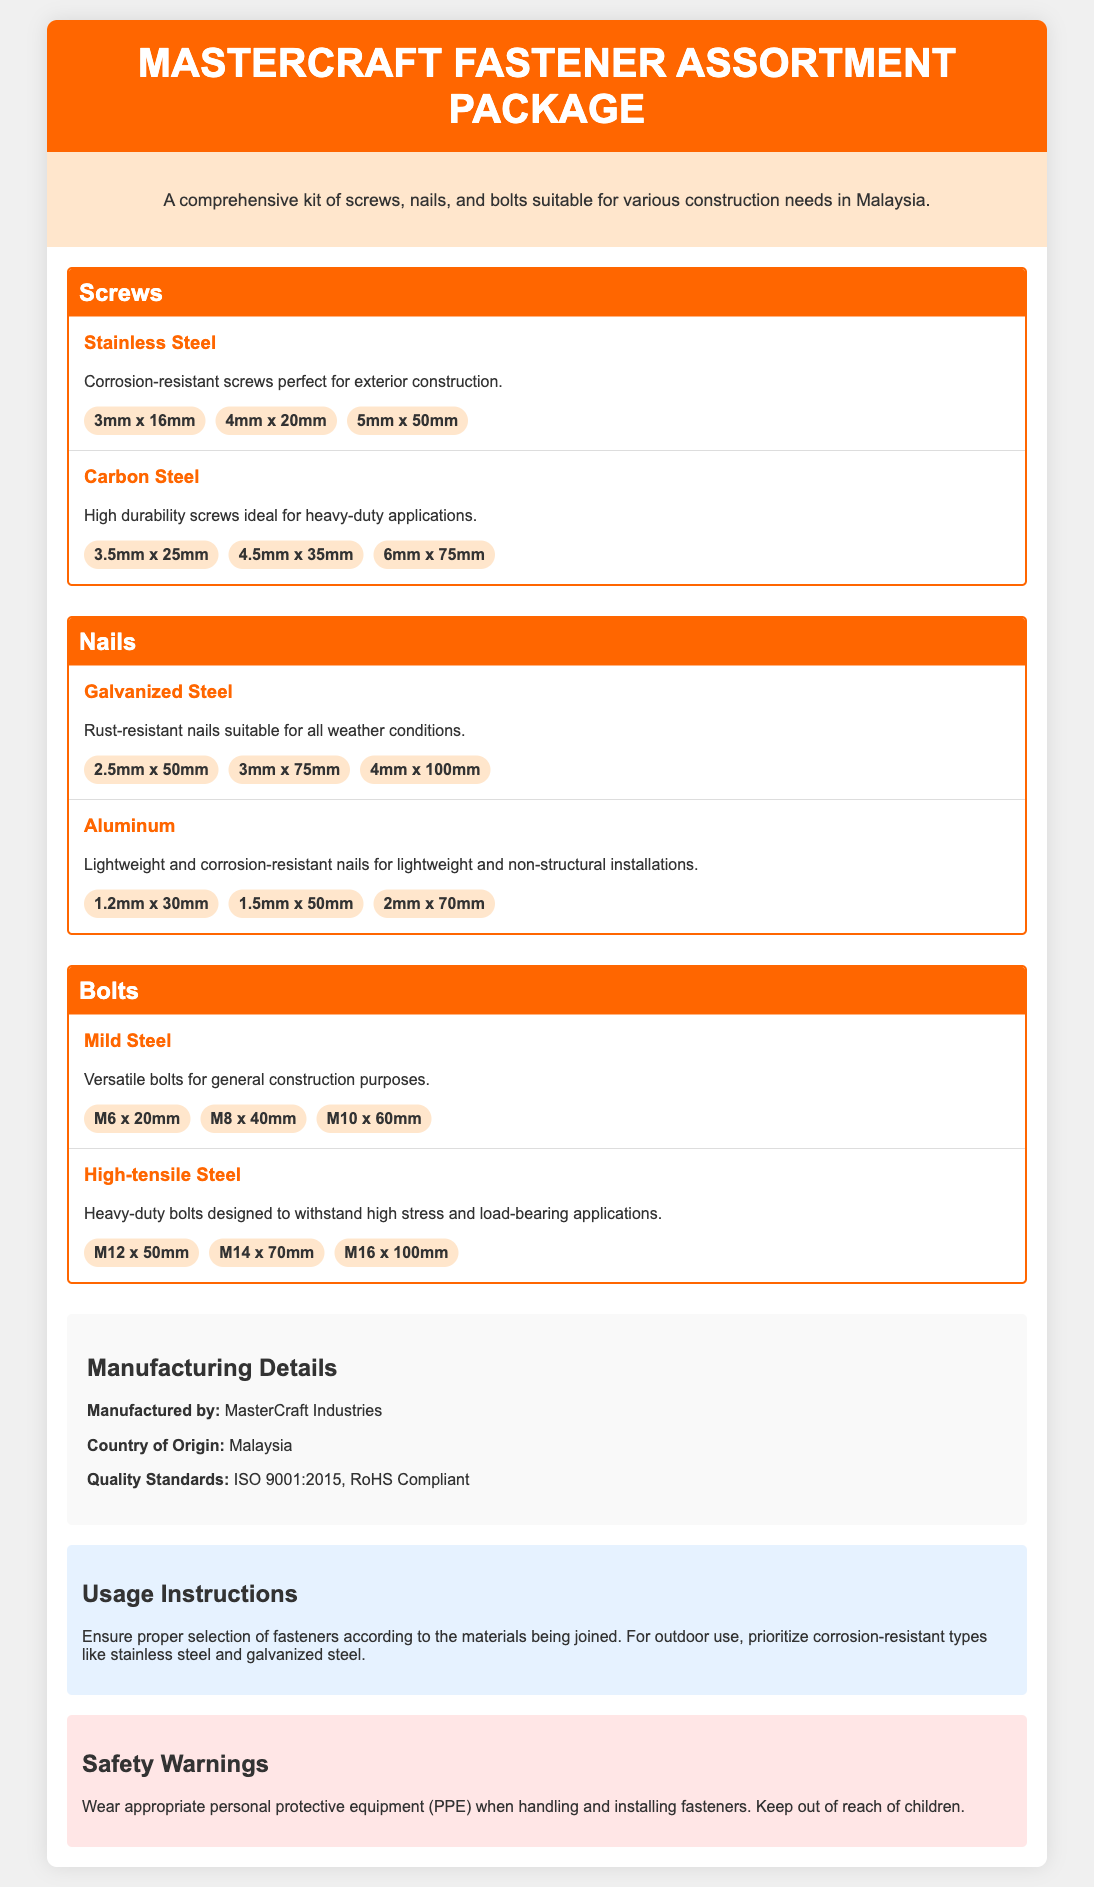What is the product name? The product name is displayed prominently in the header of the document, which is "MasterCraft Fastener Assortment Package."
Answer: MasterCraft Fastener Assortment Package How many types of screws are listed? The document categorizes fasteners into screws, nails, and bolts, specifically stating the types of screws included. There are two types listed: Stainless Steel and Carbon Steel.
Answer: 2 What material type is used for nails? The document mentions two material types for nails: Galvanized Steel and Aluminum.
Answer: Galvanized Steel, Aluminum What size variant is available for stainless steel screws? The document lists the specific sizes available for stainless steel screws, showing components such as "3mm x 16mm," "4mm x 20mm," and "5mm x 50mm."
Answer: 3mm x 16mm, 4mm x 20mm, 5mm x 50mm Who manufactures the fastener assortment package? The document specifies the manufacturer under the section "Manufacturing Details," stating "MasterCraft Industries."
Answer: MasterCraft Industries What safety warning is provided in the document? The document includes a safety warning that mentions the importance of wearing appropriate personal protective equipment and keeping the fasteners out of reach of children.
Answer: Wear appropriate personal protective equipment (PPE) What quality standard is mentioned? The document notes that the product complies with standard quality guidelines, specifically "ISO 9001:2015."
Answer: ISO 9001:2015 What is the origin country of the product? The document states the country of origin for the fastener assortment package under the manufacturing details.
Answer: Malaysia 